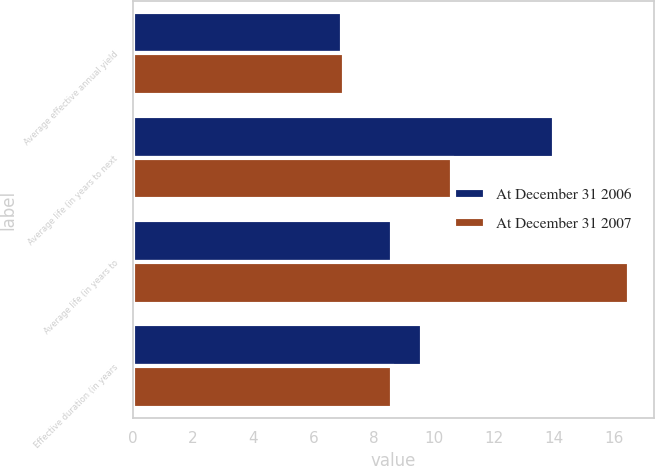Convert chart. <chart><loc_0><loc_0><loc_500><loc_500><stacked_bar_chart><ecel><fcel>Average effective annual yield<fcel>Average life (in years to next<fcel>Average life (in years to<fcel>Effective duration (in years<nl><fcel>At December 31 2006<fcel>6.96<fcel>14<fcel>8.6<fcel>9.6<nl><fcel>At December 31 2007<fcel>7.02<fcel>10.6<fcel>16.5<fcel>8.6<nl></chart> 